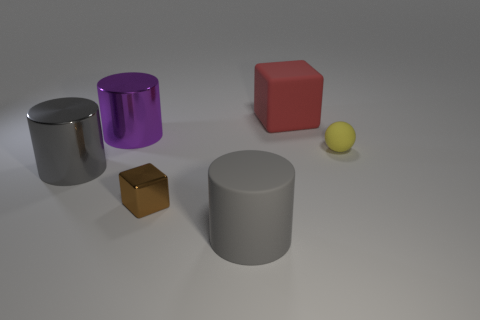Subtract all large metal cylinders. How many cylinders are left? 1 Subtract all brown blocks. How many gray cylinders are left? 2 Add 1 tiny purple shiny cylinders. How many objects exist? 7 Subtract 1 cylinders. How many cylinders are left? 2 Subtract all cubes. How many objects are left? 4 Add 4 tiny brown metallic blocks. How many tiny brown metallic blocks are left? 5 Add 6 tiny cyan things. How many tiny cyan things exist? 6 Subtract 0 cyan spheres. How many objects are left? 6 Subtract all gray blocks. Subtract all blue cylinders. How many blocks are left? 2 Subtract all big red rubber blocks. Subtract all gray cylinders. How many objects are left? 3 